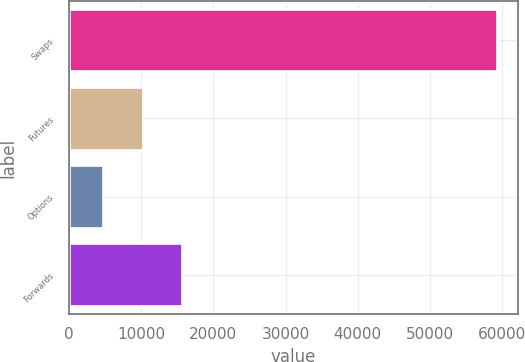Convert chart. <chart><loc_0><loc_0><loc_500><loc_500><bar_chart><fcel>Swaps<fcel>Futures<fcel>Options<fcel>Forwards<nl><fcel>59266<fcel>10209.7<fcel>4759<fcel>15660.4<nl></chart> 